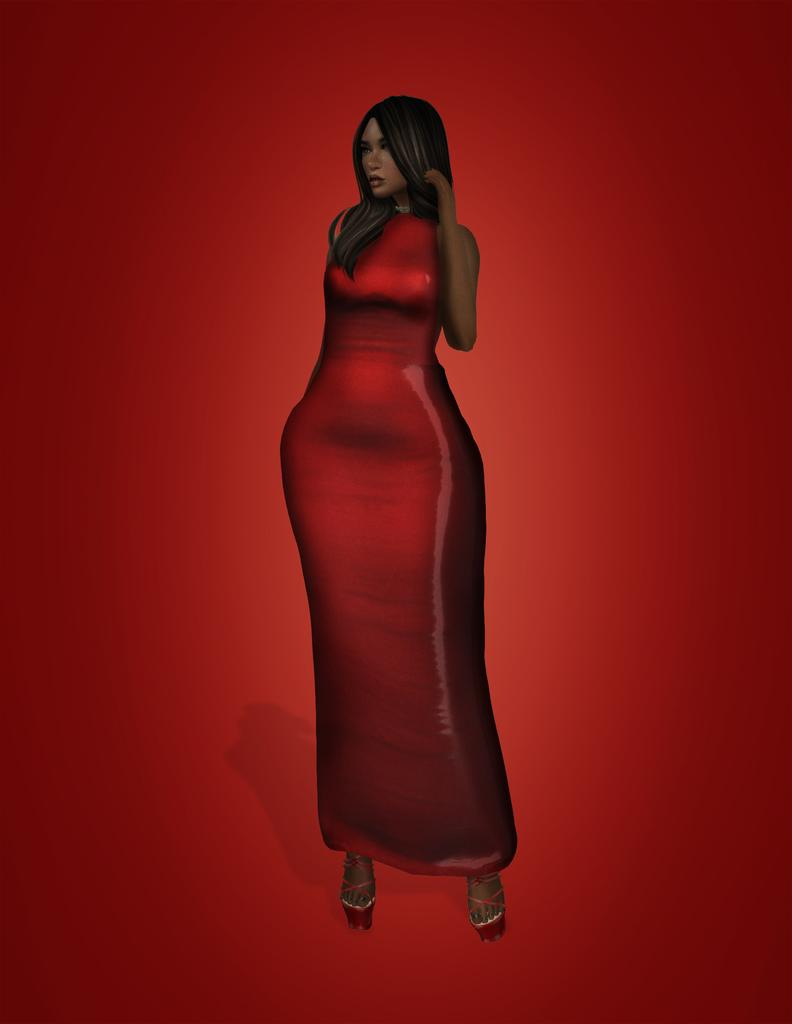Who is present in the image? There is a woman in the image. What is the woman doing in the image? The woman is standing on a surface. What type of chair is the woman sitting on in the image? There is no chair present in the image; the woman is standing on a surface. What kind of basket is the woman carrying in the image? There is no basket present in the image; the woman is standing on a surface. 